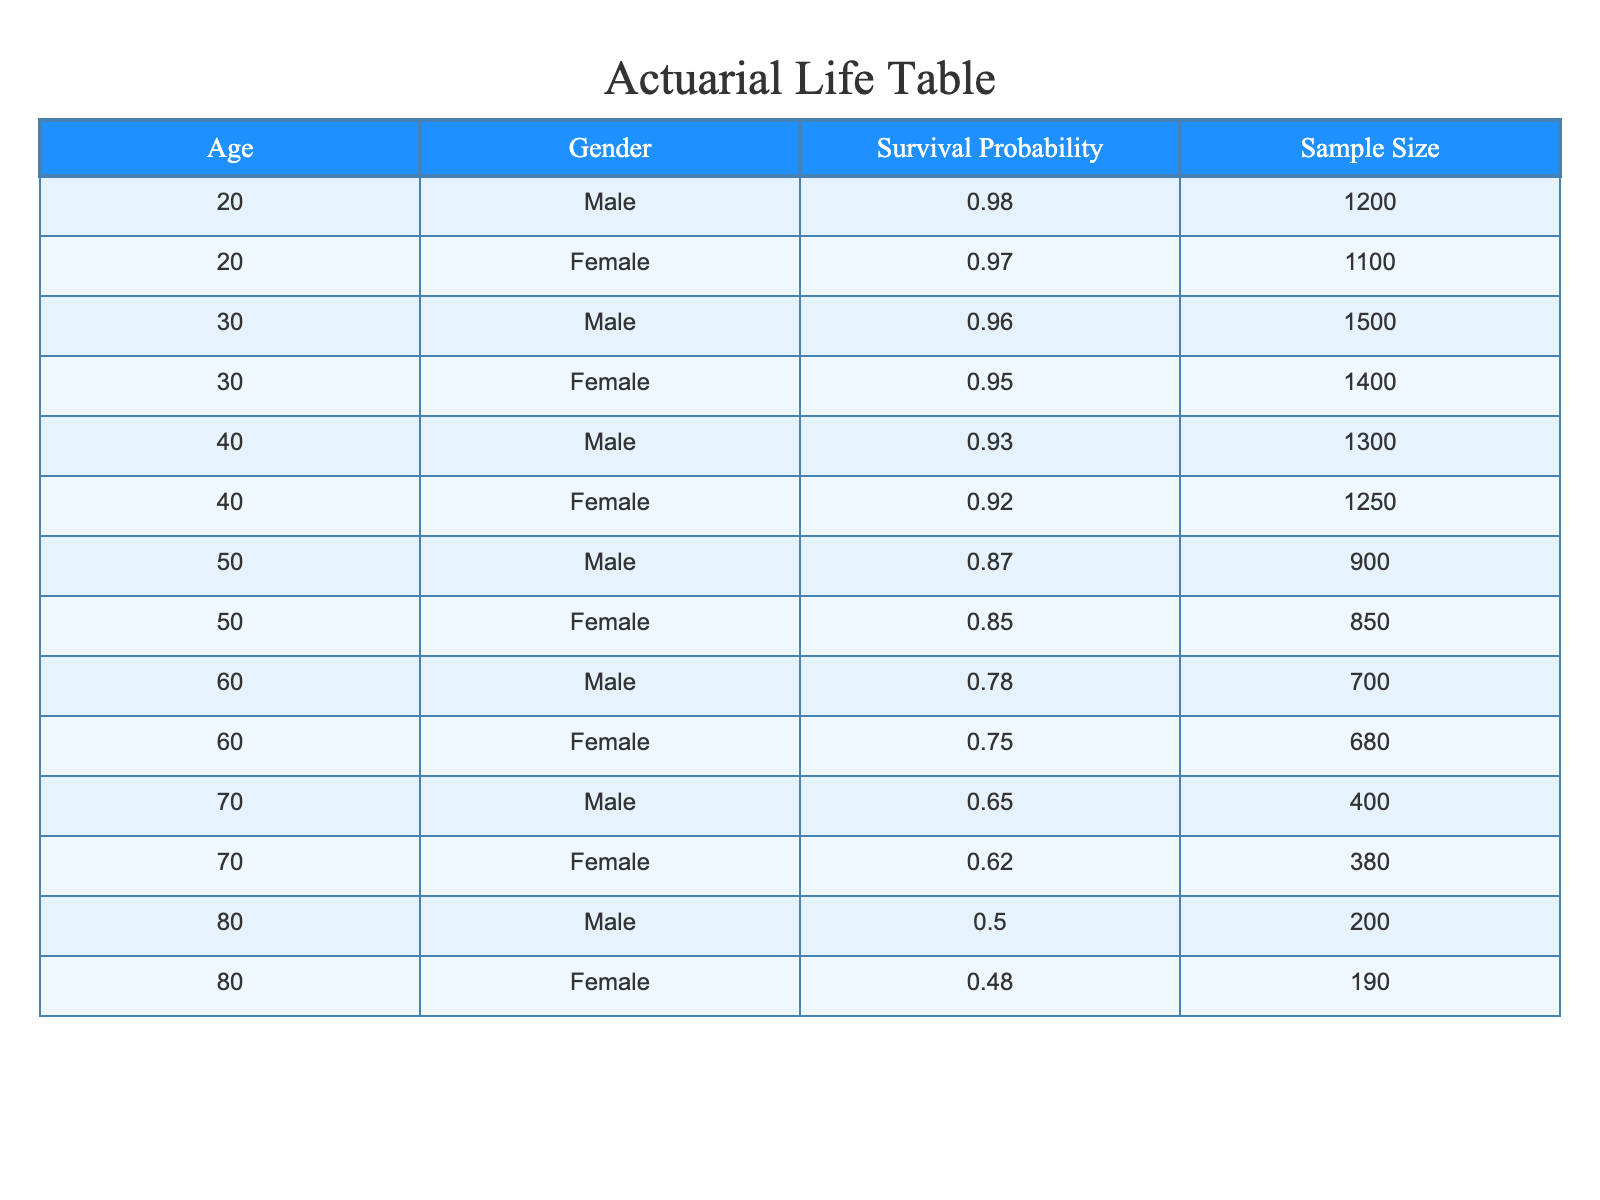What is the survival probability for a 60-year-old male after major surgery? The table shows that for a 60-year-old male, the survival probability is listed under the corresponding age and gender row. It specifically states that the survival probability is 0.78.
Answer: 0.78 What is the sample size for 40-year-old females? By referring to the row for 40-year-old females, the sample size is directly provided in the table. It indicates that there are 1250 individuals in this category.
Answer: 1250 What is the difference in survival probabilities between 30-year-old males and females after surgery? First, we locate the survival probabilities for both 30-year-old males (0.96) and females (0.95) in the table. Then, we calculate the difference: 0.96 - 0.95 = 0.01.
Answer: 0.01 Is the survival probability for 70-year-old females higher than that for 60-year-old males? From the table, the survival probability for 70-year-old females is 0.62, and for 60-year-old males, it is 0.78. We compare the two values: 0.62 < 0.78, thus the statement is false.
Answer: No What is the average survival probability for males across all age groups listed? We sum the survival probabilities of males (0.98, 0.96, 0.93, 0.87, 0.78, 0.65, 0.50) which totals to 5.67. There are 7 age groups for males, so dividing 5.67 by 7 gives us an average of approximately 0.81.
Answer: 0.81 What is the survival probability for an 80-year-old female? Referring to the corresponding row for 80-year-old females, the table indicates that their survival probability is 0.48.
Answer: 0.48 Are there more females or males in the 50-year-old age group based on the sample size? For 50-year-olds, the sample sizes are 900 for males and 850 for females. Therefore, we compare the two: since 900 > 850, there are more males.
Answer: Males What is the cumulative survival probability for all females aged 40 and above? We need to find the survival probabilities for females aged 40 (0.92), 50 (0.85), 60 (0.75), 70 (0.62), and 80 (0.48), then sum them: 0.92 + 0.85 + 0.75 + 0.62 + 0.48 = 3.62. The cumulative survival probability across those ages is 3.62.
Answer: 3.62 Is it true that the survival probability increases with age for males? We examine the survival probabilities for males at different age intervals: 20 (0.98), 30 (0.96), 40 (0.93), 50 (0.87), 60 (0.78), 70 (0.65), and 80 (0.50). The values show a decreasing trend as age increases. Thus, the statement is false.
Answer: No 